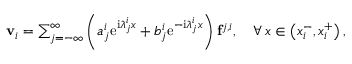Convert formula to latex. <formula><loc_0><loc_0><loc_500><loc_500>\begin{array} { r } { v _ { i } = \sum _ { j = - \infty } ^ { \infty } \left ( a _ { j } ^ { i } e ^ { i \lambda _ { j } ^ { i } x } + b _ { j } ^ { i } e ^ { - i \lambda _ { j } ^ { i } x } \right ) f ^ { j , i } , \quad \forall \, x \in \left ( x _ { i } ^ { - } , x _ { i } ^ { + } \right ) , } \end{array}</formula> 